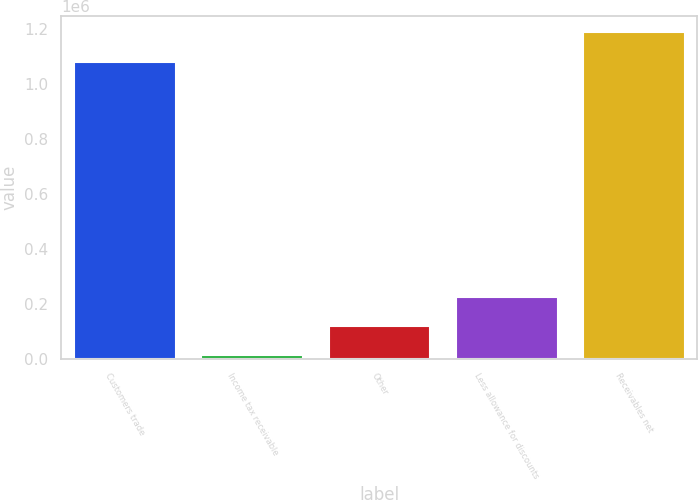Convert chart to OTSL. <chart><loc_0><loc_0><loc_500><loc_500><bar_chart><fcel>Customers trade<fcel>Income tax receivable<fcel>Other<fcel>Less allowance for discounts<fcel>Receivables net<nl><fcel>1.08149e+06<fcel>12301<fcel>119267<fcel>226233<fcel>1.18846e+06<nl></chart> 